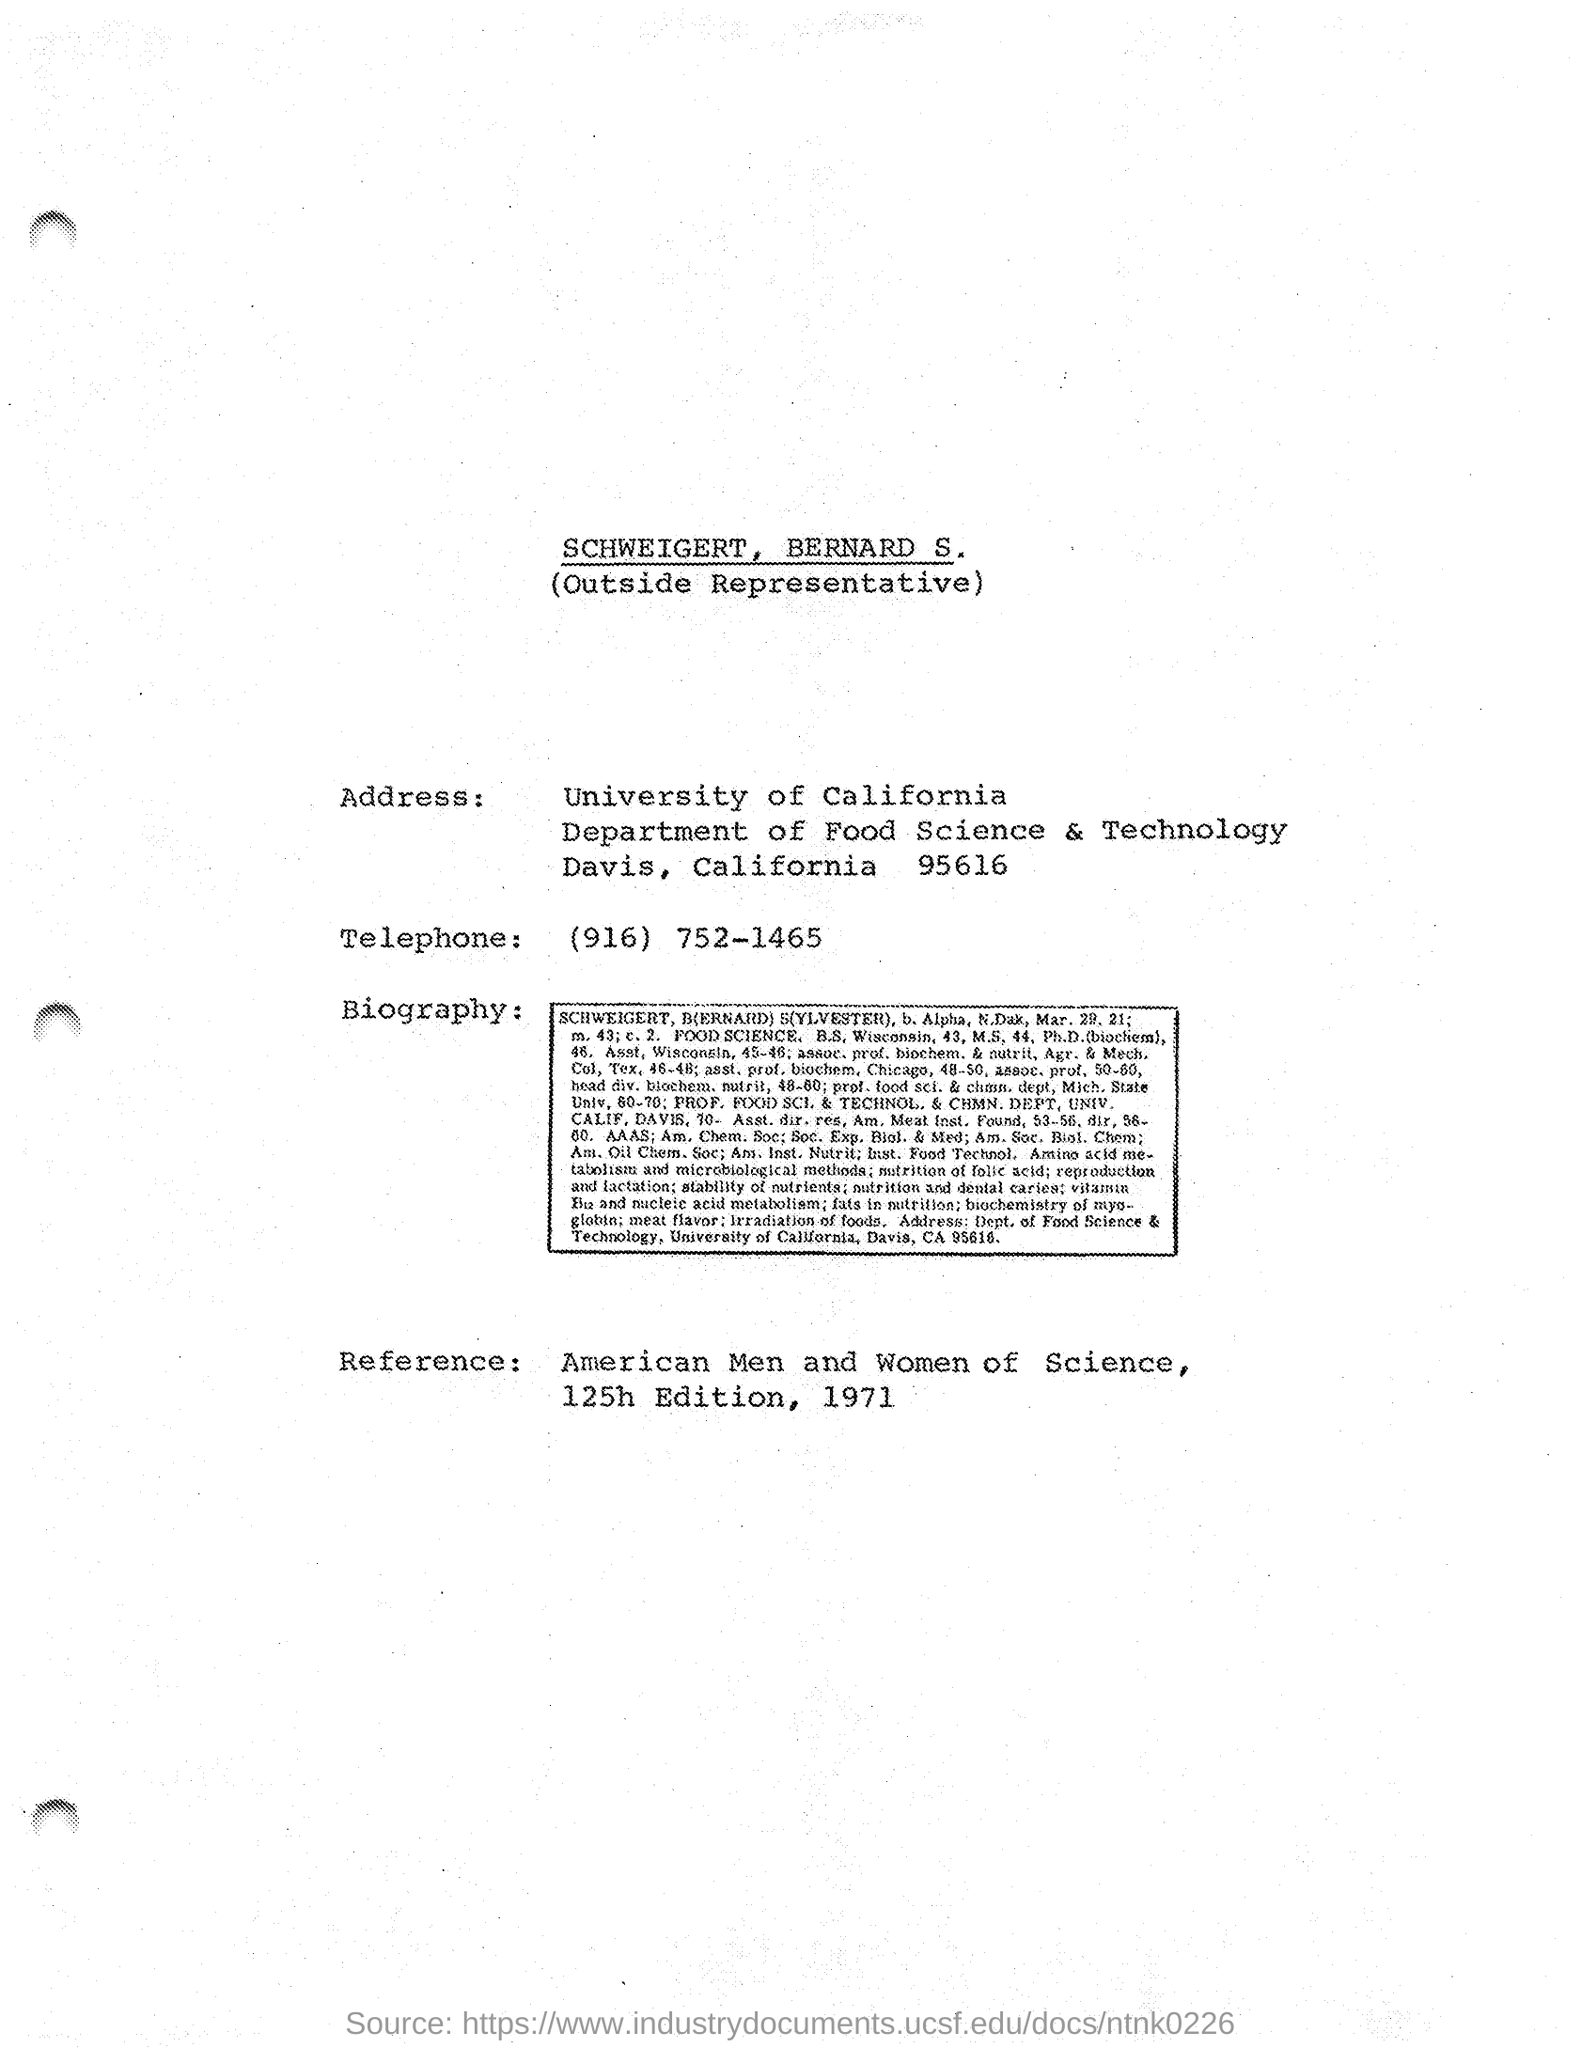Which department is mentioned in the Address?
Offer a very short reply. Department of food science & technology. What is the Telephone number of the University of California?
Provide a short and direct response. (916) 752-1465. 